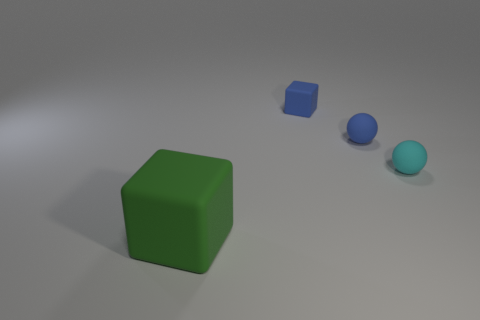Add 4 green matte blocks. How many objects exist? 8 Add 2 tiny objects. How many tiny objects exist? 5 Subtract 0 red blocks. How many objects are left? 4 Subtract all large green things. Subtract all tiny blue things. How many objects are left? 1 Add 2 small cubes. How many small cubes are left? 3 